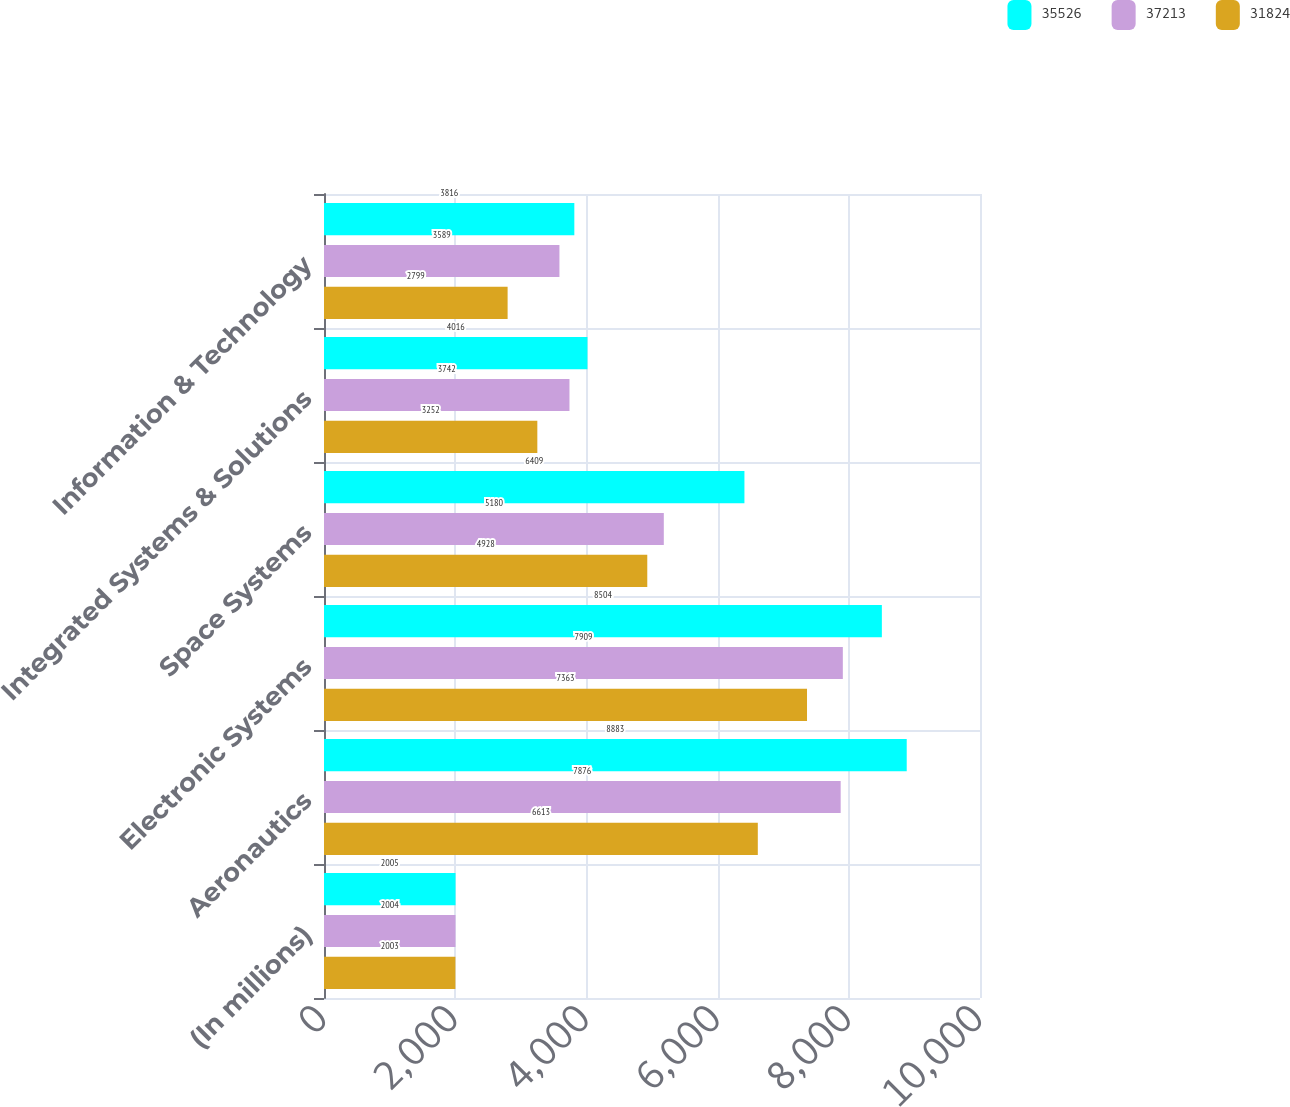Convert chart. <chart><loc_0><loc_0><loc_500><loc_500><stacked_bar_chart><ecel><fcel>(In millions)<fcel>Aeronautics<fcel>Electronic Systems<fcel>Space Systems<fcel>Integrated Systems & Solutions<fcel>Information & Technology<nl><fcel>35526<fcel>2005<fcel>8883<fcel>8504<fcel>6409<fcel>4016<fcel>3816<nl><fcel>37213<fcel>2004<fcel>7876<fcel>7909<fcel>5180<fcel>3742<fcel>3589<nl><fcel>31824<fcel>2003<fcel>6613<fcel>7363<fcel>4928<fcel>3252<fcel>2799<nl></chart> 